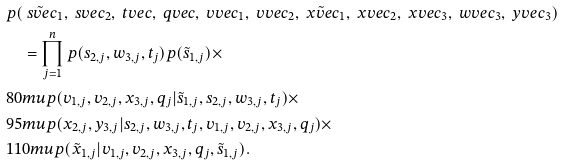<formula> <loc_0><loc_0><loc_500><loc_500>& p ( \tilde { \ s v e c } _ { 1 } , \ s v e c _ { 2 } , \ t v e c , \ q v e c , \ v v e c _ { 1 } , \ v v e c _ { 2 } , \tilde { \ x v e c } _ { 1 } , \ x v e c _ { 2 } , \ x v e c _ { 3 } , \ w v e c _ { 3 } , \ y v e c _ { 3 } ) \\ & \quad = \prod _ { j = 1 } ^ { n } { p ( s _ { 2 , j } , w _ { 3 , j } , t _ { j } ) p ( \tilde { s } _ { 1 , j } ) } \times \\ & { 8 0 m u } p ( v _ { 1 , j } , v _ { 2 , j } , x _ { 3 , j } , q _ { j } | \tilde { s } _ { 1 , j } , s _ { 2 , j } , w _ { 3 , j } , t _ { j } ) \times \\ & { 9 5 m u } p ( x _ { 2 , j } , y _ { 3 , j } | s _ { 2 , j } , w _ { 3 , j } , t _ { j } , v _ { 1 , j } , v _ { 2 , j } , x _ { 3 , j } , q _ { j } ) \times \\ & { 1 1 0 m u } p ( \tilde { x } _ { 1 , j } | v _ { 1 , j } , v _ { 2 , j } , x _ { 3 , j } , q _ { j } , \tilde { s } _ { 1 , j } ) .</formula> 